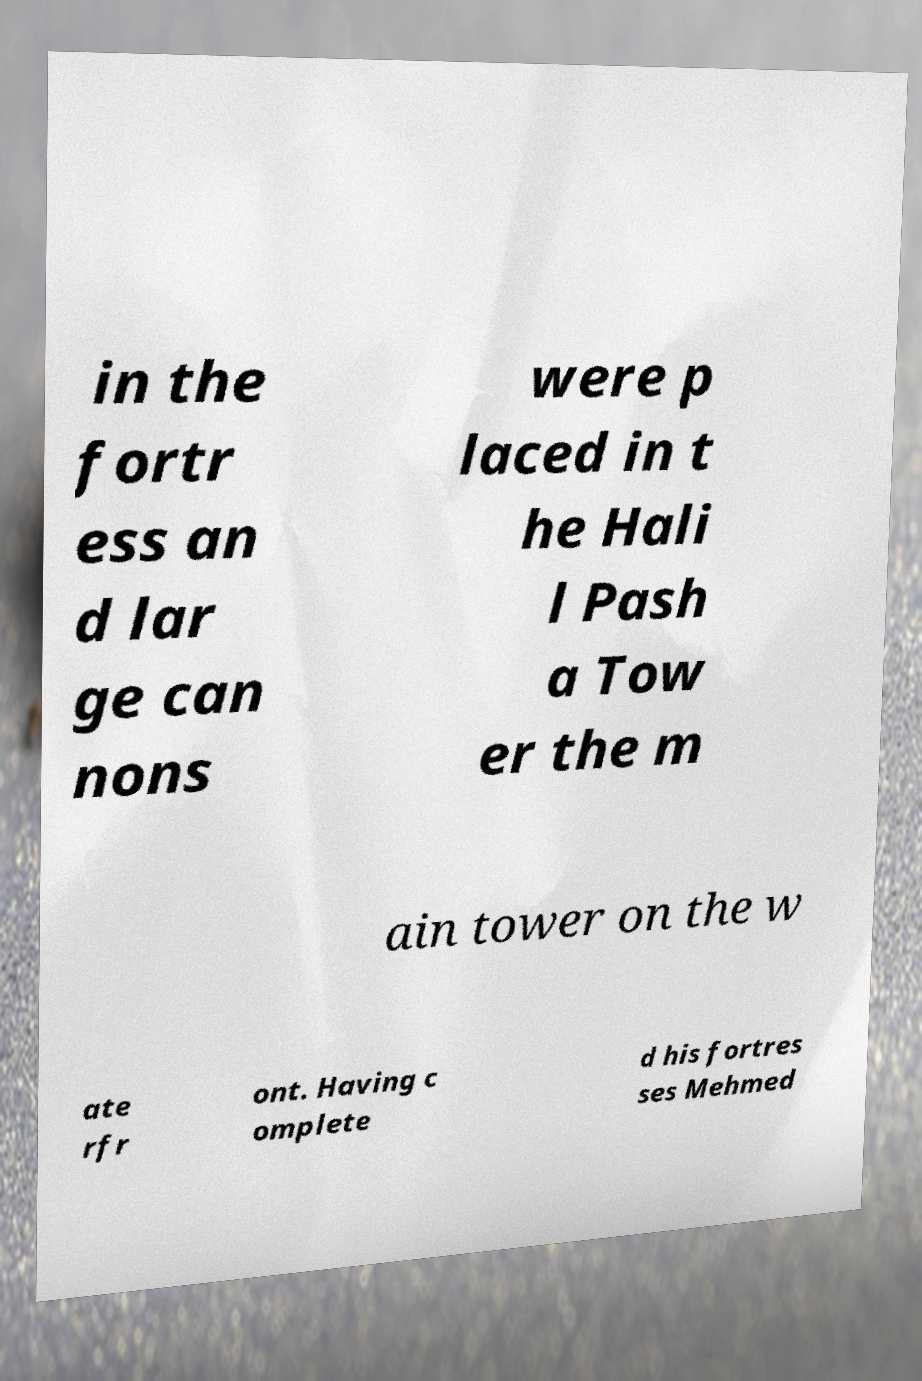Please identify and transcribe the text found in this image. in the fortr ess an d lar ge can nons were p laced in t he Hali l Pash a Tow er the m ain tower on the w ate rfr ont. Having c omplete d his fortres ses Mehmed 